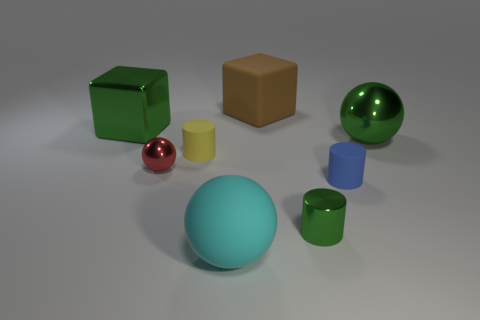Add 1 large green blocks. How many objects exist? 9 Subtract all cylinders. How many objects are left? 5 Subtract all big cyan shiny objects. Subtract all spheres. How many objects are left? 5 Add 8 red balls. How many red balls are left? 9 Add 7 small cyan cylinders. How many small cyan cylinders exist? 7 Subtract 1 green spheres. How many objects are left? 7 